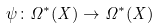<formula> <loc_0><loc_0><loc_500><loc_500>\psi \colon \Omega ^ { * } ( X ) \to \Omega ^ { * } ( X )</formula> 